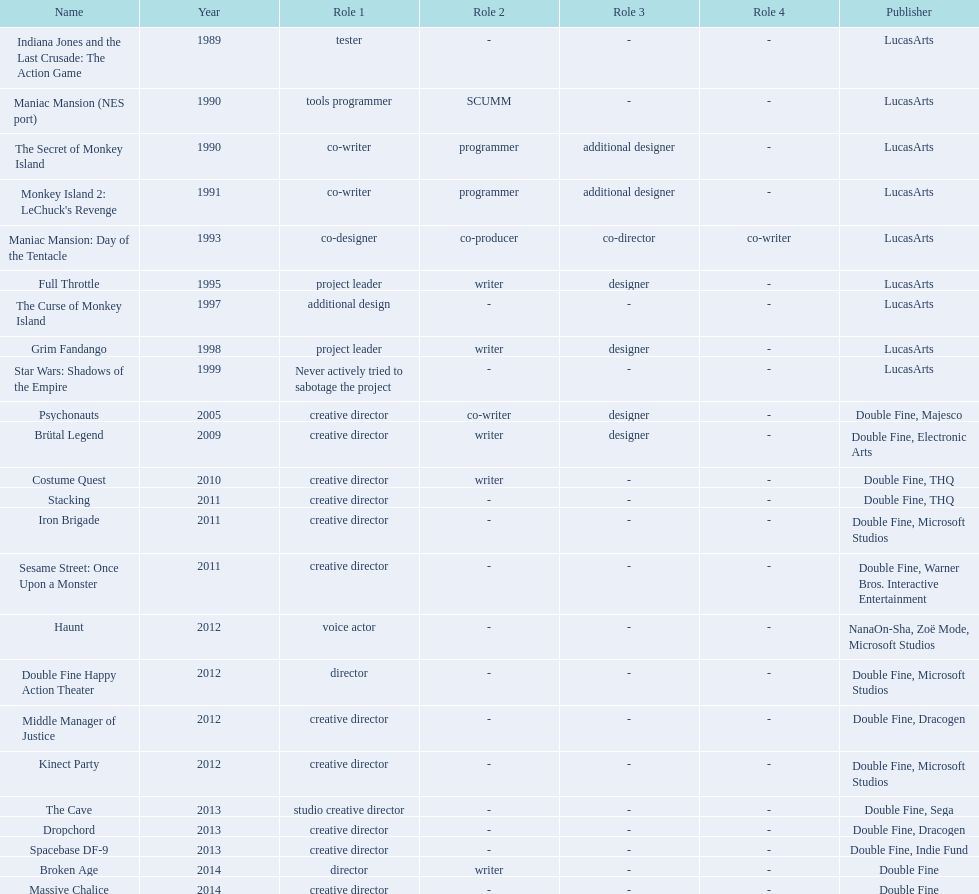Which productions did tim schafer work on that were published in part by double fine? Psychonauts, Brütal Legend, Costume Quest, Stacking, Iron Brigade, Sesame Street: Once Upon a Monster, Double Fine Happy Action Theater, Middle Manager of Justice, Kinect Party, The Cave, Dropchord, Spacebase DF-9, Broken Age, Massive Chalice. Which of these was he a creative director? Psychonauts, Brütal Legend, Costume Quest, Stacking, Iron Brigade, Sesame Street: Once Upon a Monster, Middle Manager of Justice, Kinect Party, The Cave, Dropchord, Spacebase DF-9, Massive Chalice. Which of those were in 2011? Stacking, Iron Brigade, Sesame Street: Once Upon a Monster. What was the only one of these to be co published by warner brothers? Sesame Street: Once Upon a Monster. 